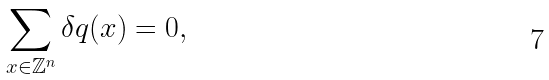Convert formula to latex. <formula><loc_0><loc_0><loc_500><loc_500>\sum _ { x \in { \mathbb { Z } } ^ { n } } \delta q ( x ) = 0 ,</formula> 